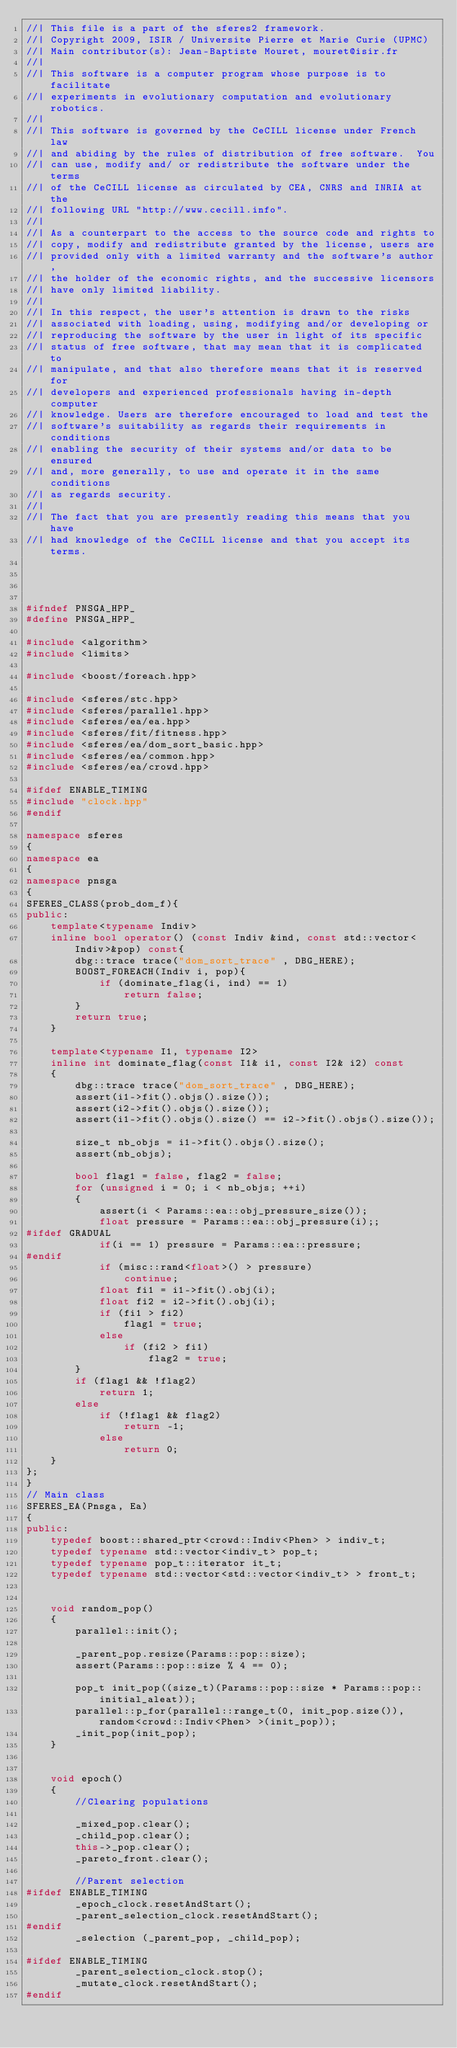<code> <loc_0><loc_0><loc_500><loc_500><_C++_>//| This file is a part of the sferes2 framework.
//| Copyright 2009, ISIR / Universite Pierre et Marie Curie (UPMC)
//| Main contributor(s): Jean-Baptiste Mouret, mouret@isir.fr
//|
//| This software is a computer program whose purpose is to facilitate
//| experiments in evolutionary computation and evolutionary robotics.
//|
//| This software is governed by the CeCILL license under French law
//| and abiding by the rules of distribution of free software.  You
//| can use, modify and/ or redistribute the software under the terms
//| of the CeCILL license as circulated by CEA, CNRS and INRIA at the
//| following URL "http://www.cecill.info".
//|
//| As a counterpart to the access to the source code and rights to
//| copy, modify and redistribute granted by the license, users are
//| provided only with a limited warranty and the software's author,
//| the holder of the economic rights, and the successive licensors
//| have only limited liability.
//|
//| In this respect, the user's attention is drawn to the risks
//| associated with loading, using, modifying and/or developing or
//| reproducing the software by the user in light of its specific
//| status of free software, that may mean that it is complicated to
//| manipulate, and that also therefore means that it is reserved for
//| developers and experienced professionals having in-depth computer
//| knowledge. Users are therefore encouraged to load and test the
//| software's suitability as regards their requirements in conditions
//| enabling the security of their systems and/or data to be ensured
//| and, more generally, to use and operate it in the same conditions
//| as regards security.
//|
//| The fact that you are presently reading this means that you have
//| had knowledge of the CeCILL license and that you accept its terms.




#ifndef PNSGA_HPP_
#define PNSGA_HPP_

#include <algorithm>
#include <limits>

#include <boost/foreach.hpp>

#include <sferes/stc.hpp>
#include <sferes/parallel.hpp>
#include <sferes/ea/ea.hpp>
#include <sferes/fit/fitness.hpp>
#include <sferes/ea/dom_sort_basic.hpp>
#include <sferes/ea/common.hpp>
#include <sferes/ea/crowd.hpp>

#ifdef ENABLE_TIMING
#include "clock.hpp"
#endif

namespace sferes
{
namespace ea
{
namespace pnsga
{
SFERES_CLASS(prob_dom_f){
public:
    template<typename Indiv>
    inline bool operator() (const Indiv &ind, const std::vector<Indiv>&pop) const{
        dbg::trace trace("dom_sort_trace" , DBG_HERE);
        BOOST_FOREACH(Indiv i, pop){
            if (dominate_flag(i, ind) == 1)
                return false;
        }
        return true;
    }

    template<typename I1, typename I2>
    inline int dominate_flag(const I1& i1, const I2& i2) const
    {
        dbg::trace trace("dom_sort_trace" , DBG_HERE);
        assert(i1->fit().objs().size());
        assert(i2->fit().objs().size());
        assert(i1->fit().objs().size() == i2->fit().objs().size());

        size_t nb_objs = i1->fit().objs().size();
        assert(nb_objs);

        bool flag1 = false, flag2 = false;
        for (unsigned i = 0; i < nb_objs; ++i)
        {
            assert(i < Params::ea::obj_pressure_size());
            float pressure = Params::ea::obj_pressure(i);;
#ifdef GRADUAL
            if(i == 1) pressure = Params::ea::pressure;
#endif
            if (misc::rand<float>() > pressure)
                continue;
            float fi1 = i1->fit().obj(i);
            float fi2 = i2->fit().obj(i);
            if (fi1 > fi2)
                flag1 = true;
            else
                if (fi2 > fi1)
                    flag2 = true;
        }
        if (flag1 && !flag2)
            return 1;
        else
            if (!flag1 && flag2)
                return -1;
            else
                return 0;
    }
};
}
// Main class
SFERES_EA(Pnsga, Ea)
{
public:
    typedef boost::shared_ptr<crowd::Indiv<Phen> > indiv_t;
    typedef typename std::vector<indiv_t> pop_t;
    typedef typename pop_t::iterator it_t;
    typedef typename std::vector<std::vector<indiv_t> > front_t;


    void random_pop()
    {
        parallel::init();

        _parent_pop.resize(Params::pop::size);
        assert(Params::pop::size % 4 == 0);

        pop_t init_pop((size_t)(Params::pop::size * Params::pop::initial_aleat));
        parallel::p_for(parallel::range_t(0, init_pop.size()), random<crowd::Indiv<Phen> >(init_pop));
        _init_pop(init_pop);
    }


    void epoch()
    {
        //Clearing populations

        _mixed_pop.clear();
        _child_pop.clear();
        this->_pop.clear();
        _pareto_front.clear();

        //Parent selection
#ifdef ENABLE_TIMING
        _epoch_clock.resetAndStart();
        _parent_selection_clock.resetAndStart();
#endif
        _selection (_parent_pop, _child_pop);

#ifdef ENABLE_TIMING
        _parent_selection_clock.stop();
        _mutate_clock.resetAndStart();
#endif
</code> 